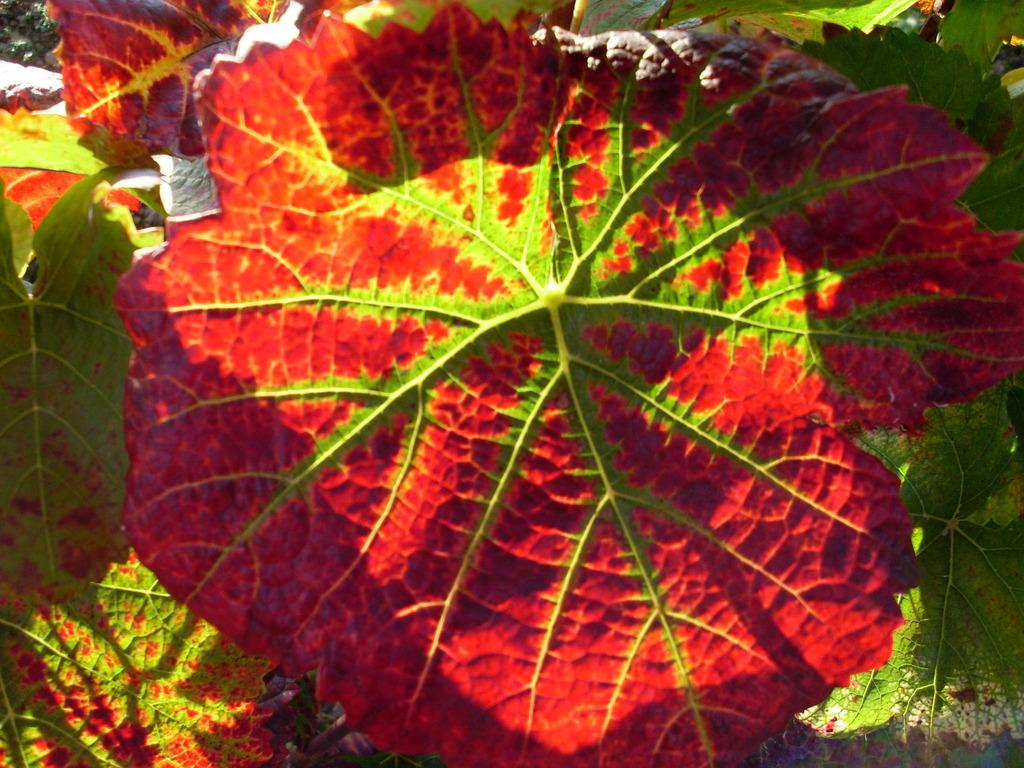What colors of leaves can be seen in the image? There are red and green color leaves in the image. Is there a minister giving a speech at the cemetery in the image? There is no mention of a minister or a cemetery in the image; it only features red and green color leaves. 